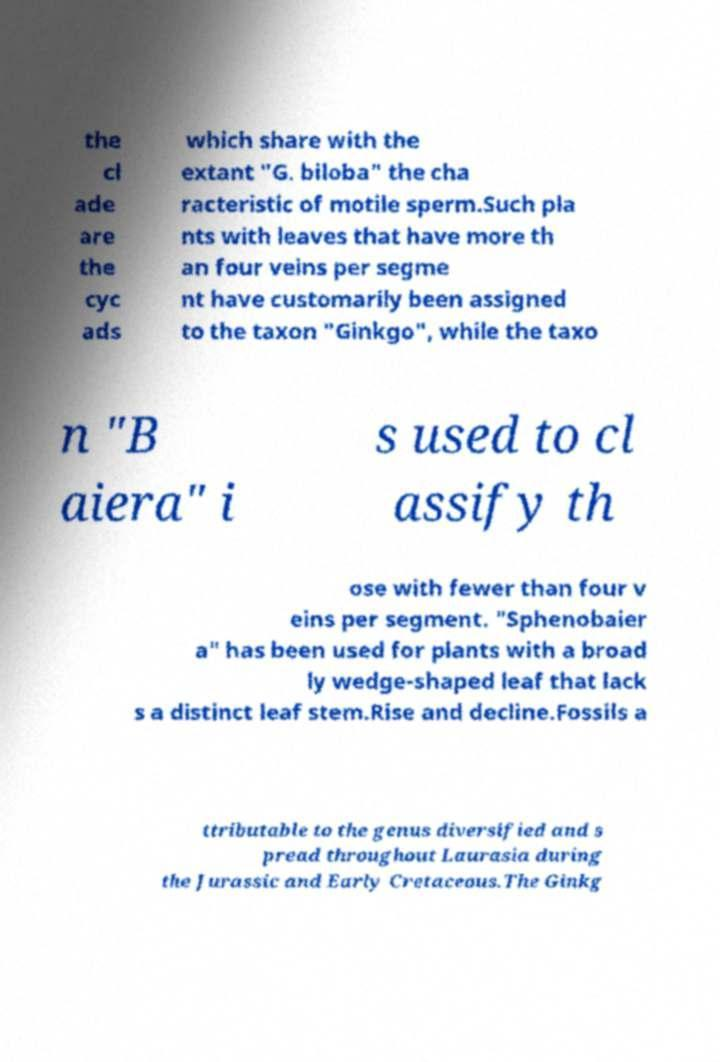What messages or text are displayed in this image? I need them in a readable, typed format. the cl ade are the cyc ads which share with the extant "G. biloba" the cha racteristic of motile sperm.Such pla nts with leaves that have more th an four veins per segme nt have customarily been assigned to the taxon "Ginkgo", while the taxo n "B aiera" i s used to cl assify th ose with fewer than four v eins per segment. "Sphenobaier a" has been used for plants with a broad ly wedge-shaped leaf that lack s a distinct leaf stem.Rise and decline.Fossils a ttributable to the genus diversified and s pread throughout Laurasia during the Jurassic and Early Cretaceous.The Ginkg 